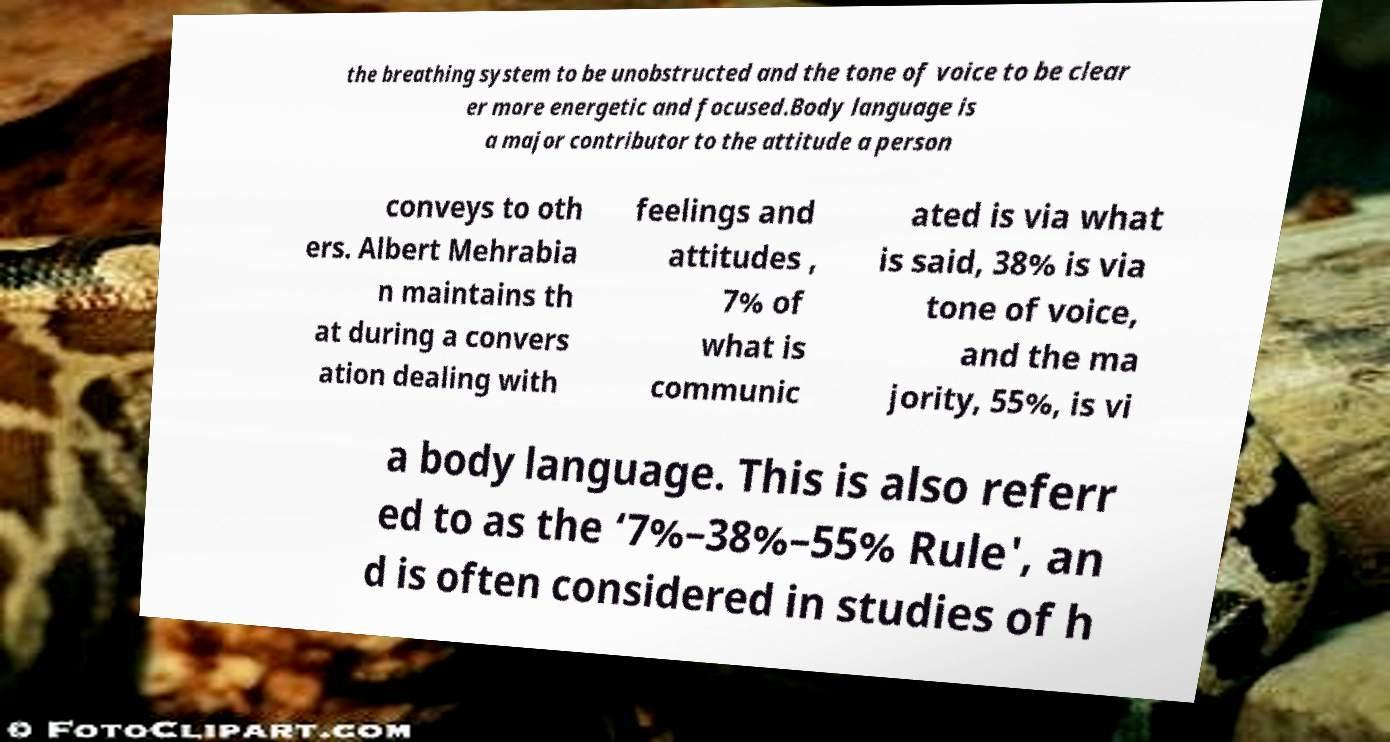What messages or text are displayed in this image? I need them in a readable, typed format. the breathing system to be unobstructed and the tone of voice to be clear er more energetic and focused.Body language is a major contributor to the attitude a person conveys to oth ers. Albert Mehrabia n maintains th at during a convers ation dealing with feelings and attitudes , 7% of what is communic ated is via what is said, 38% is via tone of voice, and the ma jority, 55%, is vi a body language. This is also referr ed to as the ‘7%–38%–55% Rule', an d is often considered in studies of h 